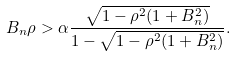<formula> <loc_0><loc_0><loc_500><loc_500>B _ { n } \rho > \alpha \frac { \sqrt { 1 - \rho ^ { 2 } ( 1 + B _ { n } ^ { 2 } ) } } { 1 - \sqrt { 1 - \rho ^ { 2 } ( 1 + B _ { n } ^ { 2 } ) } } .</formula> 